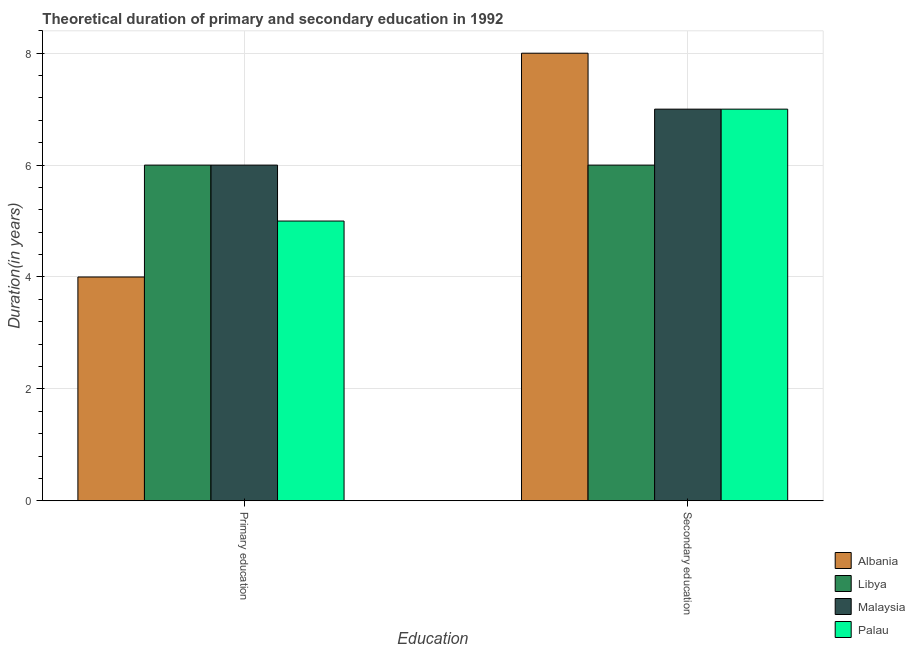How many groups of bars are there?
Make the answer very short. 2. Are the number of bars on each tick of the X-axis equal?
Provide a short and direct response. Yes. How many bars are there on the 2nd tick from the left?
Your answer should be compact. 4. What is the duration of secondary education in Albania?
Offer a terse response. 8. Across all countries, what is the maximum duration of secondary education?
Your answer should be compact. 8. Across all countries, what is the minimum duration of secondary education?
Offer a terse response. 6. In which country was the duration of secondary education maximum?
Give a very brief answer. Albania. In which country was the duration of secondary education minimum?
Your answer should be very brief. Libya. What is the total duration of secondary education in the graph?
Offer a very short reply. 28. What is the difference between the duration of primary education in Malaysia and that in Palau?
Keep it short and to the point. 1. What is the difference between the duration of primary education in Palau and the duration of secondary education in Libya?
Ensure brevity in your answer.  -1. What is the average duration of primary education per country?
Your response must be concise. 5.25. What is the difference between the duration of secondary education and duration of primary education in Albania?
Provide a succinct answer. 4. What is the ratio of the duration of primary education in Albania to that in Malaysia?
Keep it short and to the point. 0.67. Is the duration of primary education in Albania less than that in Palau?
Offer a terse response. Yes. In how many countries, is the duration of primary education greater than the average duration of primary education taken over all countries?
Your response must be concise. 2. What does the 1st bar from the left in Secondary education represents?
Your response must be concise. Albania. What does the 4th bar from the right in Primary education represents?
Offer a terse response. Albania. Are all the bars in the graph horizontal?
Provide a succinct answer. No. Does the graph contain any zero values?
Give a very brief answer. No. Does the graph contain grids?
Offer a very short reply. Yes. How are the legend labels stacked?
Offer a very short reply. Vertical. What is the title of the graph?
Keep it short and to the point. Theoretical duration of primary and secondary education in 1992. Does "Madagascar" appear as one of the legend labels in the graph?
Offer a very short reply. No. What is the label or title of the X-axis?
Offer a very short reply. Education. What is the label or title of the Y-axis?
Your answer should be compact. Duration(in years). What is the Duration(in years) of Albania in Primary education?
Your answer should be very brief. 4. What is the Duration(in years) of Malaysia in Primary education?
Provide a succinct answer. 6. What is the Duration(in years) in Albania in Secondary education?
Ensure brevity in your answer.  8. What is the Duration(in years) in Libya in Secondary education?
Make the answer very short. 6. Across all Education, what is the minimum Duration(in years) in Palau?
Keep it short and to the point. 5. What is the total Duration(in years) of Albania in the graph?
Your answer should be very brief. 12. What is the total Duration(in years) of Malaysia in the graph?
Provide a succinct answer. 13. What is the difference between the Duration(in years) of Albania in Primary education and that in Secondary education?
Keep it short and to the point. -4. What is the difference between the Duration(in years) in Libya in Primary education and that in Secondary education?
Offer a terse response. 0. What is the difference between the Duration(in years) of Malaysia in Primary education and that in Secondary education?
Your answer should be very brief. -1. What is the difference between the Duration(in years) in Palau in Primary education and that in Secondary education?
Ensure brevity in your answer.  -2. What is the difference between the Duration(in years) of Albania in Primary education and the Duration(in years) of Palau in Secondary education?
Make the answer very short. -3. What is the difference between the Duration(in years) in Libya in Primary education and the Duration(in years) in Malaysia in Secondary education?
Your answer should be compact. -1. What is the average Duration(in years) of Palau per Education?
Offer a terse response. 6. What is the difference between the Duration(in years) in Albania and Duration(in years) in Libya in Primary education?
Your answer should be very brief. -2. What is the difference between the Duration(in years) in Albania and Duration(in years) in Malaysia in Primary education?
Give a very brief answer. -2. What is the difference between the Duration(in years) in Albania and Duration(in years) in Palau in Primary education?
Give a very brief answer. -1. What is the difference between the Duration(in years) in Albania and Duration(in years) in Palau in Secondary education?
Your response must be concise. 1. What is the difference between the Duration(in years) of Libya and Duration(in years) of Malaysia in Secondary education?
Provide a short and direct response. -1. What is the ratio of the Duration(in years) in Malaysia in Primary education to that in Secondary education?
Provide a short and direct response. 0.86. What is the difference between the highest and the second highest Duration(in years) of Malaysia?
Ensure brevity in your answer.  1. What is the difference between the highest and the second highest Duration(in years) in Palau?
Make the answer very short. 2. What is the difference between the highest and the lowest Duration(in years) in Libya?
Provide a succinct answer. 0. What is the difference between the highest and the lowest Duration(in years) of Palau?
Your answer should be very brief. 2. 